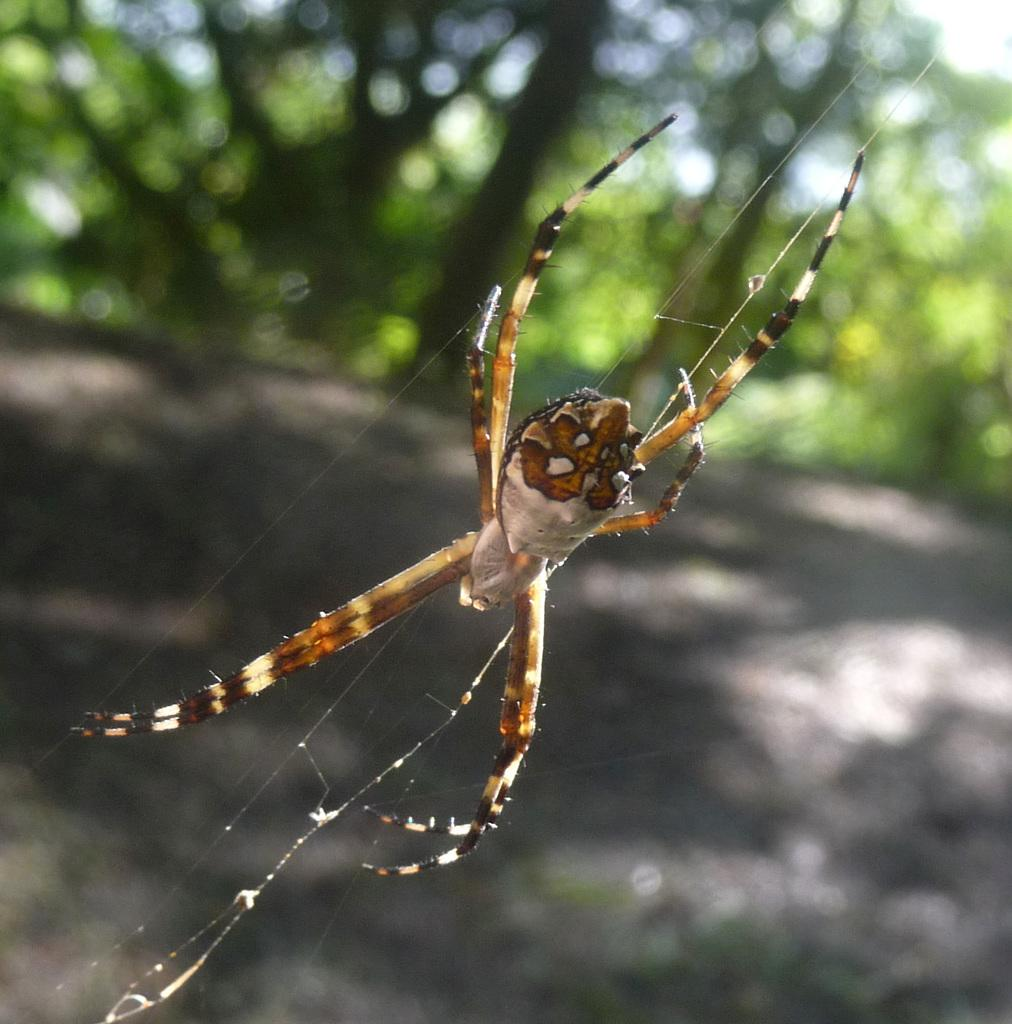What is the main subject in the center of the image? There is a spider in the center of the image. What is the spider resting on? The spider is on a web. What can be seen in the background of the image? There are trees in the background of the image. What type of hair is visible on the spider in the image? There is no hair visible on the spider in the image. Spiders do not have hair like mammals do. 